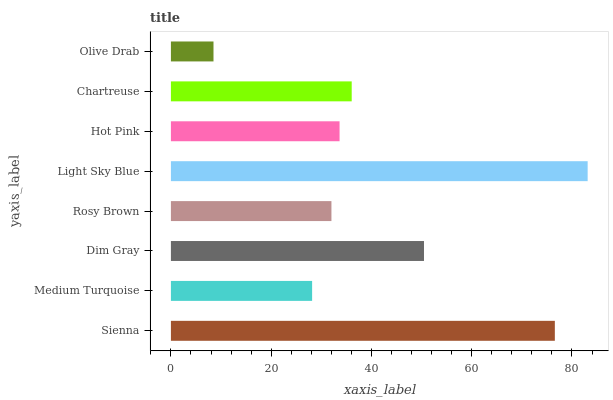Is Olive Drab the minimum?
Answer yes or no. Yes. Is Light Sky Blue the maximum?
Answer yes or no. Yes. Is Medium Turquoise the minimum?
Answer yes or no. No. Is Medium Turquoise the maximum?
Answer yes or no. No. Is Sienna greater than Medium Turquoise?
Answer yes or no. Yes. Is Medium Turquoise less than Sienna?
Answer yes or no. Yes. Is Medium Turquoise greater than Sienna?
Answer yes or no. No. Is Sienna less than Medium Turquoise?
Answer yes or no. No. Is Chartreuse the high median?
Answer yes or no. Yes. Is Hot Pink the low median?
Answer yes or no. Yes. Is Rosy Brown the high median?
Answer yes or no. No. Is Chartreuse the low median?
Answer yes or no. No. 